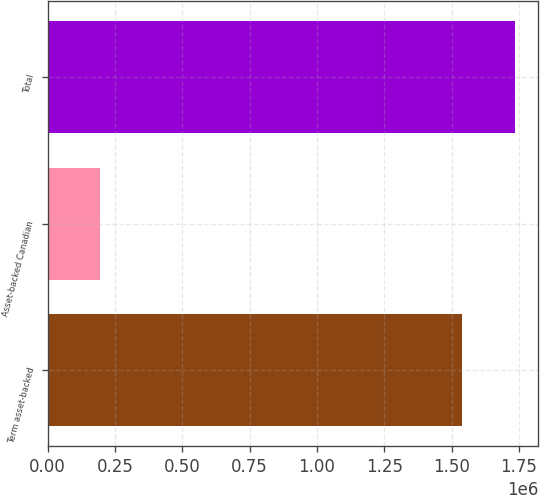Convert chart to OTSL. <chart><loc_0><loc_0><loc_500><loc_500><bar_chart><fcel>Term asset-backed<fcel>Asset-backed Canadian<fcel>Total<nl><fcel>1.53945e+06<fcel>194431<fcel>1.7343e+06<nl></chart> 